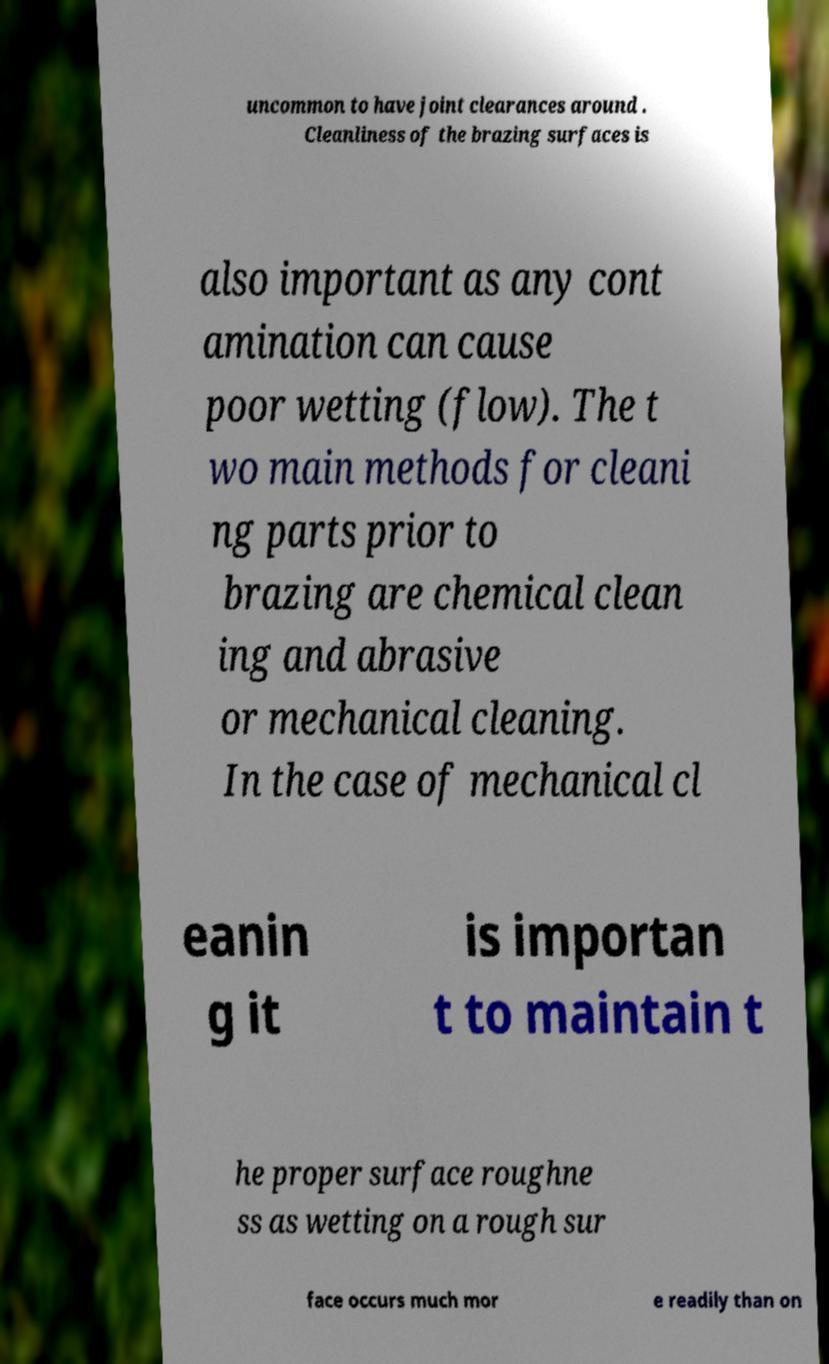Please identify and transcribe the text found in this image. uncommon to have joint clearances around . Cleanliness of the brazing surfaces is also important as any cont amination can cause poor wetting (flow). The t wo main methods for cleani ng parts prior to brazing are chemical clean ing and abrasive or mechanical cleaning. In the case of mechanical cl eanin g it is importan t to maintain t he proper surface roughne ss as wetting on a rough sur face occurs much mor e readily than on 